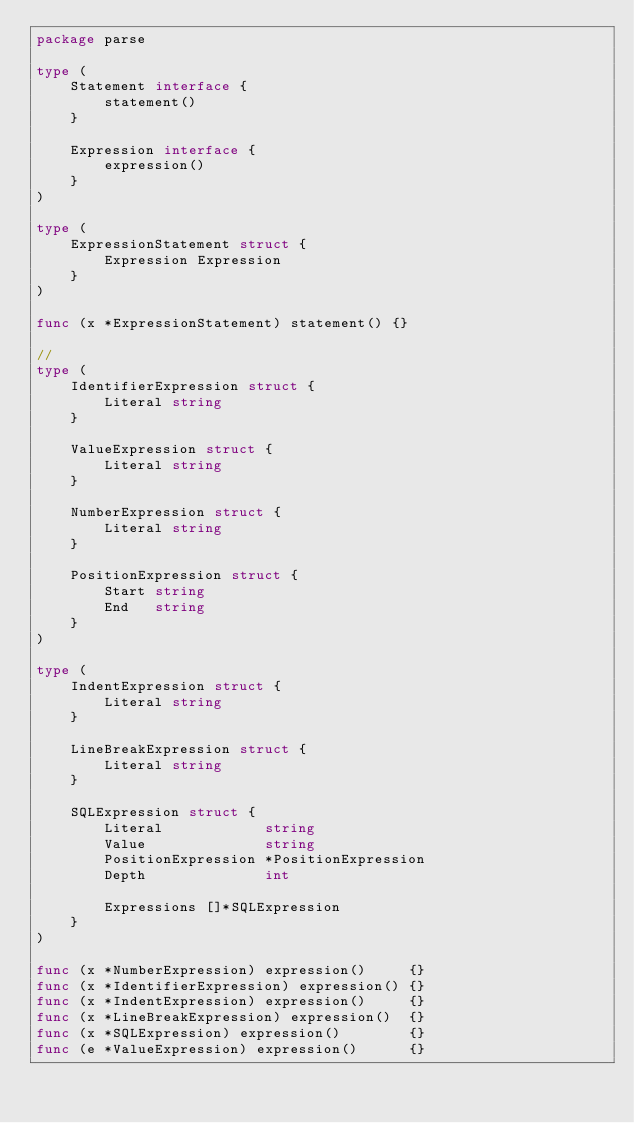<code> <loc_0><loc_0><loc_500><loc_500><_Go_>package parse

type (
	Statement interface {
		statement()
	}

	Expression interface {
		expression()
	}
)

type (
	ExpressionStatement struct {
		Expression Expression
	}
)

func (x *ExpressionStatement) statement() {}

//
type (
	IdentifierExpression struct {
		Literal string
	}

	ValueExpression struct {
		Literal string
	}

	NumberExpression struct {
		Literal string
	}

	PositionExpression struct {
		Start string
		End   string
	}
)

type (
	IndentExpression struct {
		Literal string
	}

	LineBreakExpression struct {
		Literal string
	}

	SQLExpression struct {
		Literal            string
		Value              string
		PositionExpression *PositionExpression
		Depth              int

		Expressions []*SQLExpression
	}
)

func (x *NumberExpression) expression()     {}
func (x *IdentifierExpression) expression() {}
func (x *IndentExpression) expression()     {}
func (x *LineBreakExpression) expression()  {}
func (x *SQLExpression) expression()        {}
func (e *ValueExpression) expression()      {}
</code> 